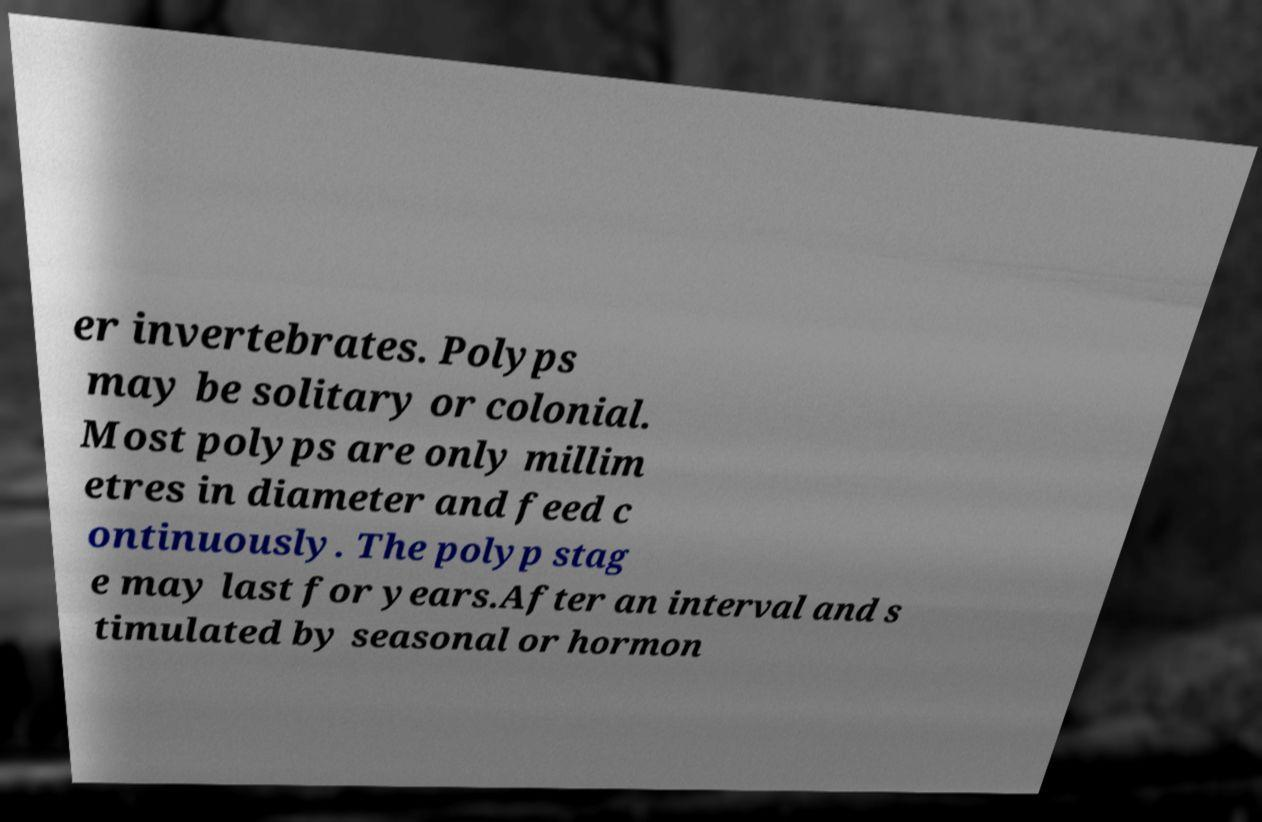There's text embedded in this image that I need extracted. Can you transcribe it verbatim? er invertebrates. Polyps may be solitary or colonial. Most polyps are only millim etres in diameter and feed c ontinuously. The polyp stag e may last for years.After an interval and s timulated by seasonal or hormon 